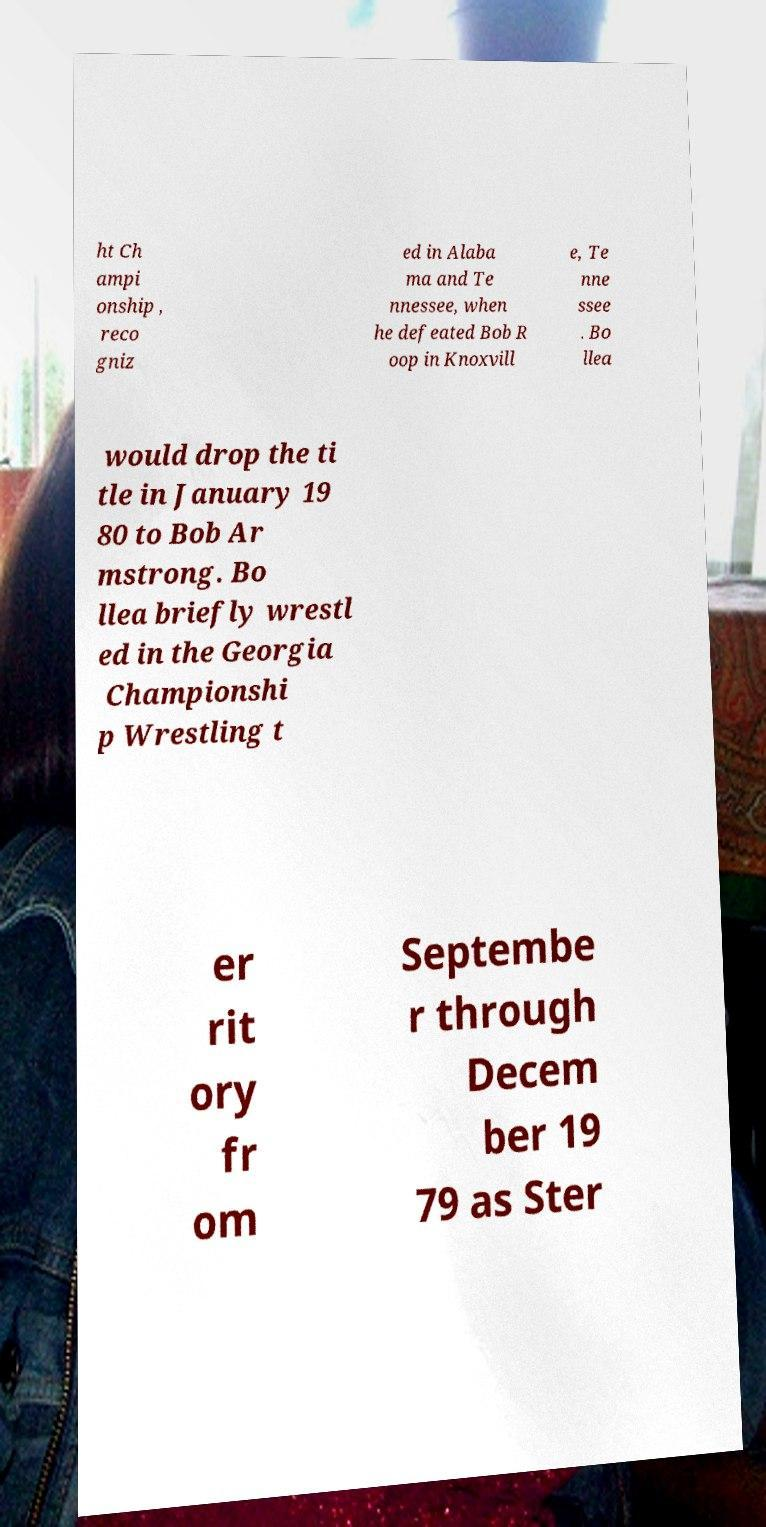Can you accurately transcribe the text from the provided image for me? ht Ch ampi onship , reco gniz ed in Alaba ma and Te nnessee, when he defeated Bob R oop in Knoxvill e, Te nne ssee . Bo llea would drop the ti tle in January 19 80 to Bob Ar mstrong. Bo llea briefly wrestl ed in the Georgia Championshi p Wrestling t er rit ory fr om Septembe r through Decem ber 19 79 as Ster 